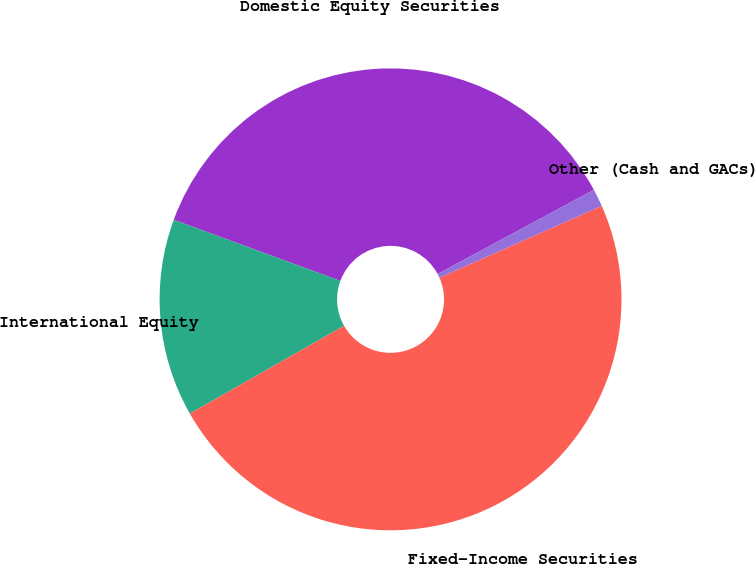<chart> <loc_0><loc_0><loc_500><loc_500><pie_chart><fcel>Domestic Equity Securities<fcel>International Equity<fcel>Fixed-Income Securities<fcel>Other (Cash and GACs)<nl><fcel>36.54%<fcel>13.83%<fcel>48.4%<fcel>1.23%<nl></chart> 